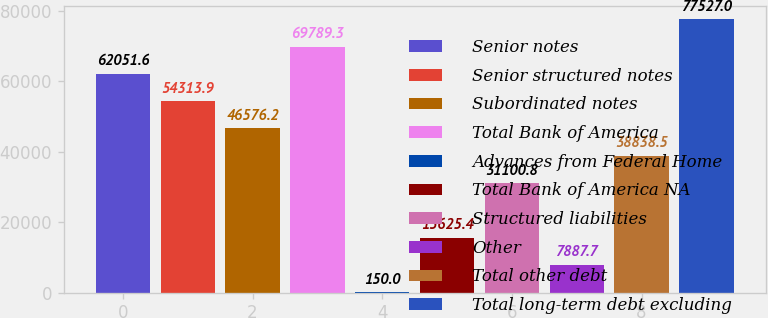<chart> <loc_0><loc_0><loc_500><loc_500><bar_chart><fcel>Senior notes<fcel>Senior structured notes<fcel>Subordinated notes<fcel>Total Bank of America<fcel>Advances from Federal Home<fcel>Total Bank of America NA<fcel>Structured liabilities<fcel>Other<fcel>Total other debt<fcel>Total long-term debt excluding<nl><fcel>62051.6<fcel>54313.9<fcel>46576.2<fcel>69789.3<fcel>150<fcel>15625.4<fcel>31100.8<fcel>7887.7<fcel>38838.5<fcel>77527<nl></chart> 